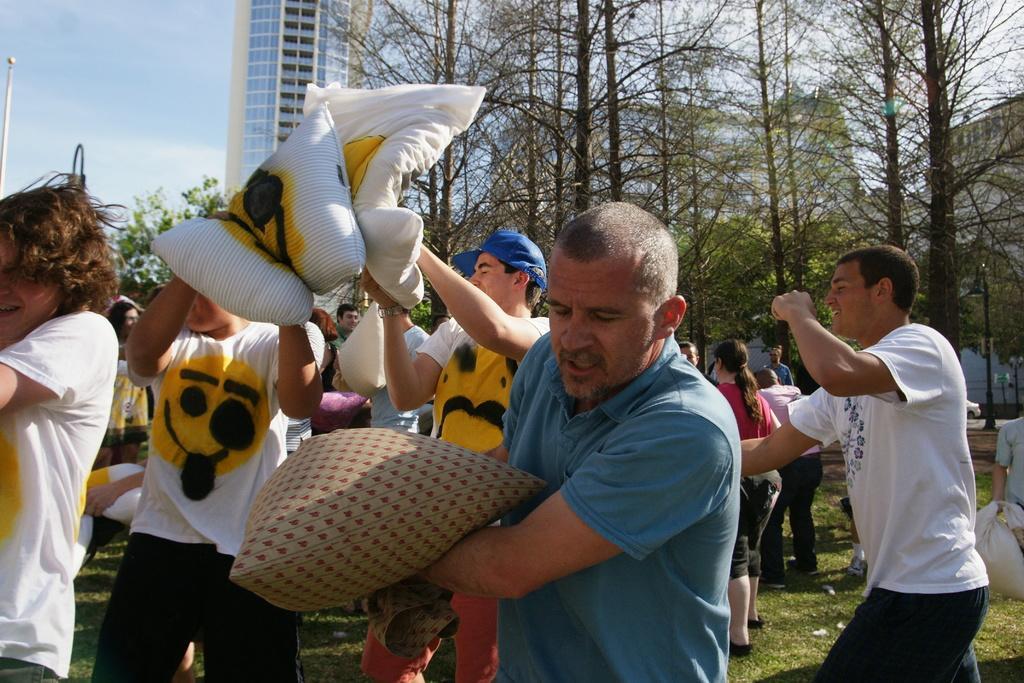Could you give a brief overview of what you see in this image? In the image we can see there are people standing on the ground and holding pillows in their hand. Behind there are trees and there is a building. 